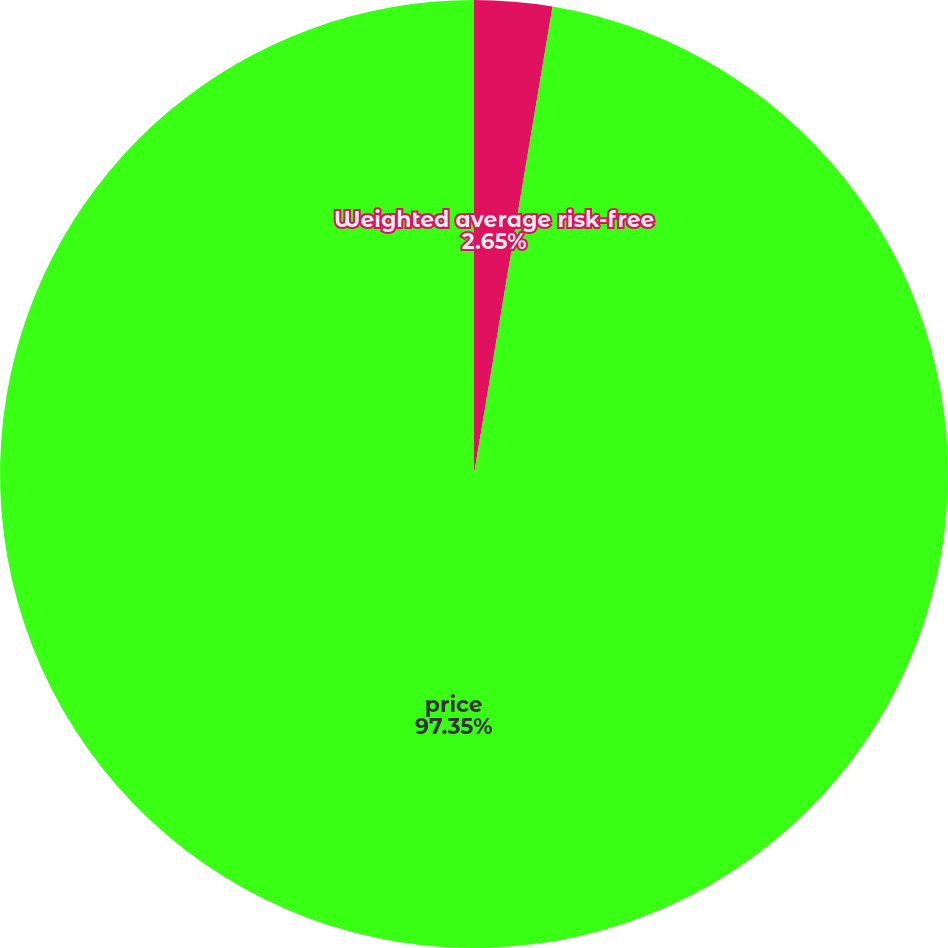Convert chart. <chart><loc_0><loc_0><loc_500><loc_500><pie_chart><fcel>Weighted average risk-free<fcel>price<nl><fcel>2.65%<fcel>97.35%<nl></chart> 